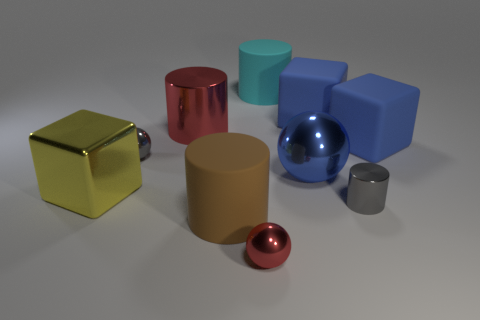The red metallic sphere is what size?
Your response must be concise. Small. How many things are either large yellow things or large rubber objects that are on the right side of the cyan matte cylinder?
Provide a short and direct response. 3. What number of other things are the same color as the tiny cylinder?
Offer a very short reply. 1. Does the yellow metal thing have the same size as the gray metallic thing that is left of the large cyan matte object?
Provide a succinct answer. No. There is a gray cylinder that is in front of the blue ball; is it the same size as the brown object?
Provide a succinct answer. No. How many other objects are there of the same material as the big blue sphere?
Provide a short and direct response. 5. Is the number of blocks behind the small gray ball the same as the number of large blue spheres in front of the big yellow cube?
Provide a succinct answer. No. The large cube that is on the left side of the rubber cylinder on the right side of the red thing in front of the large brown thing is what color?
Keep it short and to the point. Yellow. The gray metallic thing in front of the big yellow shiny thing has what shape?
Ensure brevity in your answer.  Cylinder. There is a cyan object that is the same material as the brown object; what shape is it?
Keep it short and to the point. Cylinder. 